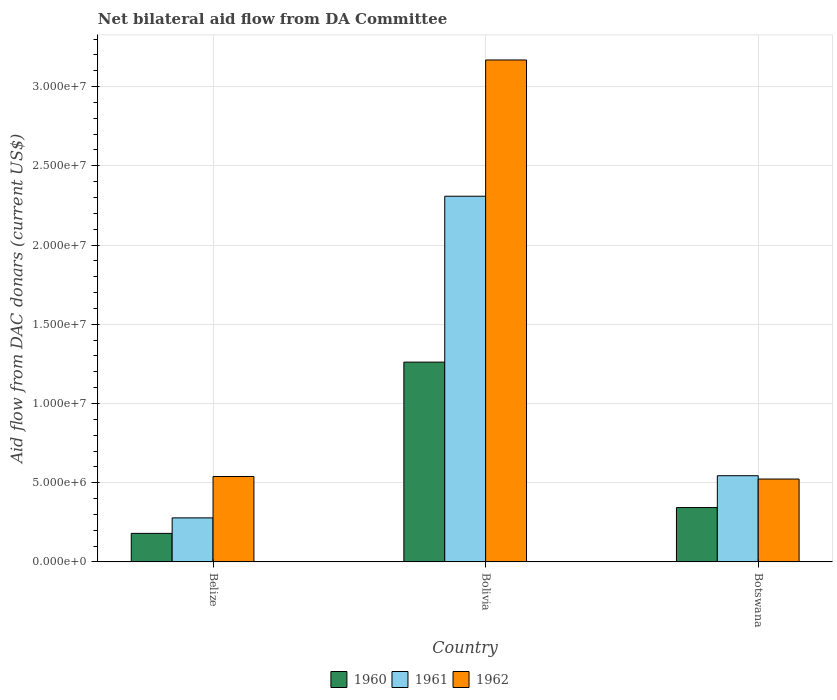Are the number of bars per tick equal to the number of legend labels?
Provide a succinct answer. Yes. How many bars are there on the 2nd tick from the left?
Provide a succinct answer. 3. How many bars are there on the 3rd tick from the right?
Keep it short and to the point. 3. What is the label of the 3rd group of bars from the left?
Your response must be concise. Botswana. In how many cases, is the number of bars for a given country not equal to the number of legend labels?
Keep it short and to the point. 0. What is the aid flow in in 1962 in Bolivia?
Give a very brief answer. 3.17e+07. Across all countries, what is the maximum aid flow in in 1962?
Your answer should be compact. 3.17e+07. Across all countries, what is the minimum aid flow in in 1960?
Ensure brevity in your answer.  1.80e+06. In which country was the aid flow in in 1962 minimum?
Provide a short and direct response. Botswana. What is the total aid flow in in 1962 in the graph?
Keep it short and to the point. 4.23e+07. What is the difference between the aid flow in in 1960 in Belize and that in Bolivia?
Keep it short and to the point. -1.08e+07. What is the difference between the aid flow in in 1962 in Botswana and the aid flow in in 1960 in Belize?
Ensure brevity in your answer.  3.43e+06. What is the average aid flow in in 1961 per country?
Your answer should be very brief. 1.04e+07. What is the difference between the aid flow in of/in 1962 and aid flow in of/in 1961 in Belize?
Provide a succinct answer. 2.61e+06. What is the ratio of the aid flow in in 1961 in Belize to that in Botswana?
Ensure brevity in your answer.  0.51. Is the aid flow in in 1960 in Belize less than that in Botswana?
Your response must be concise. Yes. Is the difference between the aid flow in in 1962 in Belize and Bolivia greater than the difference between the aid flow in in 1961 in Belize and Bolivia?
Keep it short and to the point. No. What is the difference between the highest and the second highest aid flow in in 1960?
Provide a succinct answer. 1.08e+07. What is the difference between the highest and the lowest aid flow in in 1962?
Your response must be concise. 2.64e+07. Is the sum of the aid flow in in 1961 in Bolivia and Botswana greater than the maximum aid flow in in 1960 across all countries?
Offer a very short reply. Yes. What does the 2nd bar from the left in Belize represents?
Provide a short and direct response. 1961. What does the 2nd bar from the right in Bolivia represents?
Your answer should be compact. 1961. Is it the case that in every country, the sum of the aid flow in in 1961 and aid flow in in 1960 is greater than the aid flow in in 1962?
Offer a very short reply. No. How many bars are there?
Provide a short and direct response. 9. Are all the bars in the graph horizontal?
Your response must be concise. No. What is the difference between two consecutive major ticks on the Y-axis?
Keep it short and to the point. 5.00e+06. Are the values on the major ticks of Y-axis written in scientific E-notation?
Give a very brief answer. Yes. Does the graph contain any zero values?
Your response must be concise. No. Does the graph contain grids?
Give a very brief answer. Yes. Where does the legend appear in the graph?
Give a very brief answer. Bottom center. How many legend labels are there?
Make the answer very short. 3. What is the title of the graph?
Your answer should be very brief. Net bilateral aid flow from DA Committee. What is the label or title of the X-axis?
Your answer should be compact. Country. What is the label or title of the Y-axis?
Provide a succinct answer. Aid flow from DAC donars (current US$). What is the Aid flow from DAC donars (current US$) of 1960 in Belize?
Your answer should be very brief. 1.80e+06. What is the Aid flow from DAC donars (current US$) in 1961 in Belize?
Offer a terse response. 2.78e+06. What is the Aid flow from DAC donars (current US$) of 1962 in Belize?
Offer a terse response. 5.39e+06. What is the Aid flow from DAC donars (current US$) of 1960 in Bolivia?
Ensure brevity in your answer.  1.26e+07. What is the Aid flow from DAC donars (current US$) in 1961 in Bolivia?
Provide a short and direct response. 2.31e+07. What is the Aid flow from DAC donars (current US$) of 1962 in Bolivia?
Your response must be concise. 3.17e+07. What is the Aid flow from DAC donars (current US$) in 1960 in Botswana?
Keep it short and to the point. 3.43e+06. What is the Aid flow from DAC donars (current US$) of 1961 in Botswana?
Your response must be concise. 5.44e+06. What is the Aid flow from DAC donars (current US$) of 1962 in Botswana?
Your answer should be compact. 5.23e+06. Across all countries, what is the maximum Aid flow from DAC donars (current US$) of 1960?
Your answer should be compact. 1.26e+07. Across all countries, what is the maximum Aid flow from DAC donars (current US$) of 1961?
Your answer should be very brief. 2.31e+07. Across all countries, what is the maximum Aid flow from DAC donars (current US$) of 1962?
Offer a very short reply. 3.17e+07. Across all countries, what is the minimum Aid flow from DAC donars (current US$) in 1960?
Your response must be concise. 1.80e+06. Across all countries, what is the minimum Aid flow from DAC donars (current US$) in 1961?
Make the answer very short. 2.78e+06. Across all countries, what is the minimum Aid flow from DAC donars (current US$) of 1962?
Your response must be concise. 5.23e+06. What is the total Aid flow from DAC donars (current US$) of 1960 in the graph?
Your response must be concise. 1.78e+07. What is the total Aid flow from DAC donars (current US$) of 1961 in the graph?
Provide a short and direct response. 3.13e+07. What is the total Aid flow from DAC donars (current US$) in 1962 in the graph?
Make the answer very short. 4.23e+07. What is the difference between the Aid flow from DAC donars (current US$) in 1960 in Belize and that in Bolivia?
Your response must be concise. -1.08e+07. What is the difference between the Aid flow from DAC donars (current US$) of 1961 in Belize and that in Bolivia?
Offer a very short reply. -2.03e+07. What is the difference between the Aid flow from DAC donars (current US$) of 1962 in Belize and that in Bolivia?
Ensure brevity in your answer.  -2.63e+07. What is the difference between the Aid flow from DAC donars (current US$) of 1960 in Belize and that in Botswana?
Offer a very short reply. -1.63e+06. What is the difference between the Aid flow from DAC donars (current US$) of 1961 in Belize and that in Botswana?
Give a very brief answer. -2.66e+06. What is the difference between the Aid flow from DAC donars (current US$) in 1962 in Belize and that in Botswana?
Make the answer very short. 1.60e+05. What is the difference between the Aid flow from DAC donars (current US$) of 1960 in Bolivia and that in Botswana?
Give a very brief answer. 9.18e+06. What is the difference between the Aid flow from DAC donars (current US$) in 1961 in Bolivia and that in Botswana?
Your answer should be very brief. 1.76e+07. What is the difference between the Aid flow from DAC donars (current US$) of 1962 in Bolivia and that in Botswana?
Your answer should be compact. 2.64e+07. What is the difference between the Aid flow from DAC donars (current US$) of 1960 in Belize and the Aid flow from DAC donars (current US$) of 1961 in Bolivia?
Give a very brief answer. -2.13e+07. What is the difference between the Aid flow from DAC donars (current US$) in 1960 in Belize and the Aid flow from DAC donars (current US$) in 1962 in Bolivia?
Ensure brevity in your answer.  -2.99e+07. What is the difference between the Aid flow from DAC donars (current US$) of 1961 in Belize and the Aid flow from DAC donars (current US$) of 1962 in Bolivia?
Keep it short and to the point. -2.89e+07. What is the difference between the Aid flow from DAC donars (current US$) of 1960 in Belize and the Aid flow from DAC donars (current US$) of 1961 in Botswana?
Provide a succinct answer. -3.64e+06. What is the difference between the Aid flow from DAC donars (current US$) in 1960 in Belize and the Aid flow from DAC donars (current US$) in 1962 in Botswana?
Make the answer very short. -3.43e+06. What is the difference between the Aid flow from DAC donars (current US$) in 1961 in Belize and the Aid flow from DAC donars (current US$) in 1962 in Botswana?
Keep it short and to the point. -2.45e+06. What is the difference between the Aid flow from DAC donars (current US$) in 1960 in Bolivia and the Aid flow from DAC donars (current US$) in 1961 in Botswana?
Make the answer very short. 7.17e+06. What is the difference between the Aid flow from DAC donars (current US$) of 1960 in Bolivia and the Aid flow from DAC donars (current US$) of 1962 in Botswana?
Provide a short and direct response. 7.38e+06. What is the difference between the Aid flow from DAC donars (current US$) in 1961 in Bolivia and the Aid flow from DAC donars (current US$) in 1962 in Botswana?
Give a very brief answer. 1.78e+07. What is the average Aid flow from DAC donars (current US$) in 1960 per country?
Keep it short and to the point. 5.95e+06. What is the average Aid flow from DAC donars (current US$) of 1961 per country?
Your answer should be very brief. 1.04e+07. What is the average Aid flow from DAC donars (current US$) of 1962 per country?
Give a very brief answer. 1.41e+07. What is the difference between the Aid flow from DAC donars (current US$) of 1960 and Aid flow from DAC donars (current US$) of 1961 in Belize?
Offer a very short reply. -9.80e+05. What is the difference between the Aid flow from DAC donars (current US$) of 1960 and Aid flow from DAC donars (current US$) of 1962 in Belize?
Your answer should be very brief. -3.59e+06. What is the difference between the Aid flow from DAC donars (current US$) in 1961 and Aid flow from DAC donars (current US$) in 1962 in Belize?
Offer a terse response. -2.61e+06. What is the difference between the Aid flow from DAC donars (current US$) in 1960 and Aid flow from DAC donars (current US$) in 1961 in Bolivia?
Provide a short and direct response. -1.05e+07. What is the difference between the Aid flow from DAC donars (current US$) of 1960 and Aid flow from DAC donars (current US$) of 1962 in Bolivia?
Provide a succinct answer. -1.91e+07. What is the difference between the Aid flow from DAC donars (current US$) in 1961 and Aid flow from DAC donars (current US$) in 1962 in Bolivia?
Offer a very short reply. -8.60e+06. What is the difference between the Aid flow from DAC donars (current US$) in 1960 and Aid flow from DAC donars (current US$) in 1961 in Botswana?
Keep it short and to the point. -2.01e+06. What is the difference between the Aid flow from DAC donars (current US$) of 1960 and Aid flow from DAC donars (current US$) of 1962 in Botswana?
Your answer should be very brief. -1.80e+06. What is the difference between the Aid flow from DAC donars (current US$) of 1961 and Aid flow from DAC donars (current US$) of 1962 in Botswana?
Keep it short and to the point. 2.10e+05. What is the ratio of the Aid flow from DAC donars (current US$) in 1960 in Belize to that in Bolivia?
Keep it short and to the point. 0.14. What is the ratio of the Aid flow from DAC donars (current US$) in 1961 in Belize to that in Bolivia?
Provide a short and direct response. 0.12. What is the ratio of the Aid flow from DAC donars (current US$) in 1962 in Belize to that in Bolivia?
Your answer should be compact. 0.17. What is the ratio of the Aid flow from DAC donars (current US$) in 1960 in Belize to that in Botswana?
Ensure brevity in your answer.  0.52. What is the ratio of the Aid flow from DAC donars (current US$) in 1961 in Belize to that in Botswana?
Provide a succinct answer. 0.51. What is the ratio of the Aid flow from DAC donars (current US$) of 1962 in Belize to that in Botswana?
Give a very brief answer. 1.03. What is the ratio of the Aid flow from DAC donars (current US$) of 1960 in Bolivia to that in Botswana?
Your answer should be compact. 3.68. What is the ratio of the Aid flow from DAC donars (current US$) in 1961 in Bolivia to that in Botswana?
Offer a very short reply. 4.24. What is the ratio of the Aid flow from DAC donars (current US$) of 1962 in Bolivia to that in Botswana?
Your response must be concise. 6.06. What is the difference between the highest and the second highest Aid flow from DAC donars (current US$) of 1960?
Your response must be concise. 9.18e+06. What is the difference between the highest and the second highest Aid flow from DAC donars (current US$) in 1961?
Offer a very short reply. 1.76e+07. What is the difference between the highest and the second highest Aid flow from DAC donars (current US$) in 1962?
Keep it short and to the point. 2.63e+07. What is the difference between the highest and the lowest Aid flow from DAC donars (current US$) in 1960?
Provide a short and direct response. 1.08e+07. What is the difference between the highest and the lowest Aid flow from DAC donars (current US$) of 1961?
Provide a short and direct response. 2.03e+07. What is the difference between the highest and the lowest Aid flow from DAC donars (current US$) of 1962?
Your response must be concise. 2.64e+07. 